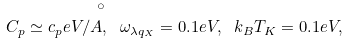Convert formula to latex. <formula><loc_0><loc_0><loc_500><loc_500>C _ { p } \simeq c _ { p } e V / \AA , \ \omega _ { \lambda { q } _ { X } } = 0 . 1 e V , \ k _ { B } T _ { K } = 0 . 1 e V ,</formula> 